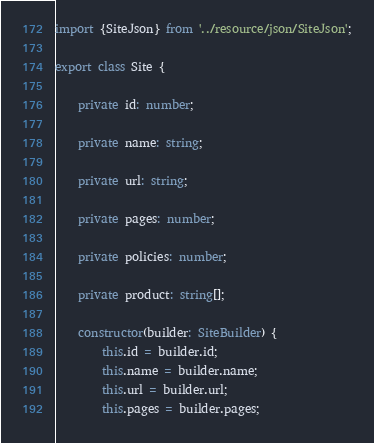Convert code to text. <code><loc_0><loc_0><loc_500><loc_500><_TypeScript_>import {SiteJson} from '../resource/json/SiteJson';

export class Site {

    private id: number;

    private name: string;

    private url: string;

    private pages: number;

    private policies: number;

    private product: string[];

    constructor(builder: SiteBuilder) {
        this.id = builder.id;
        this.name = builder.name;
        this.url = builder.url;
        this.pages = builder.pages;</code> 